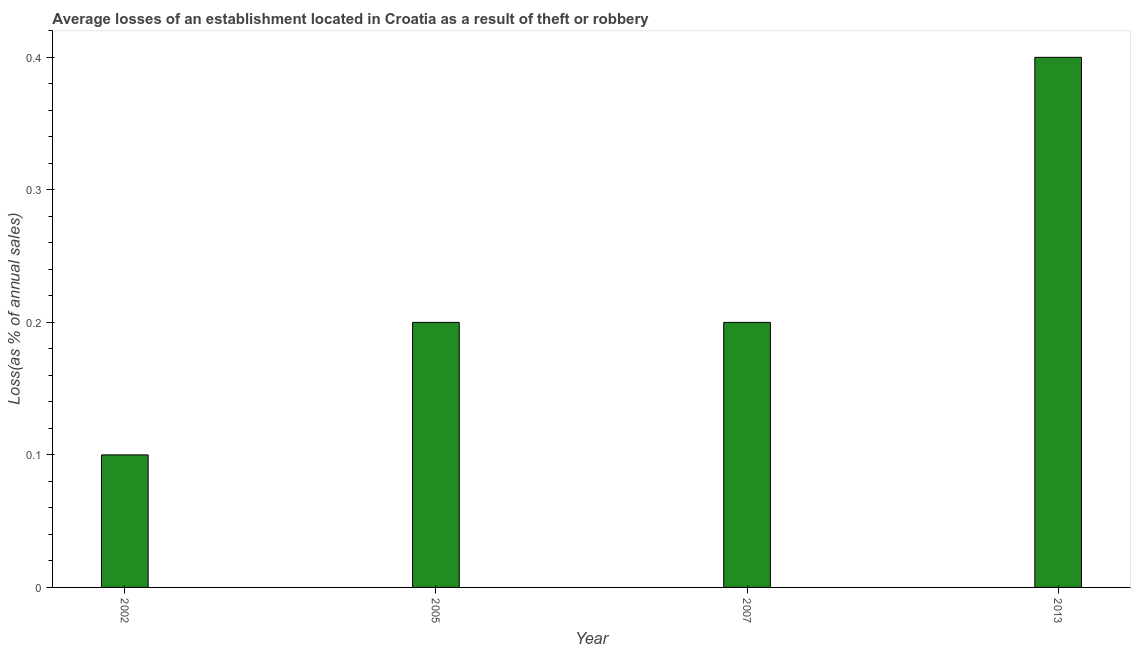Does the graph contain any zero values?
Make the answer very short. No. What is the title of the graph?
Provide a short and direct response. Average losses of an establishment located in Croatia as a result of theft or robbery. What is the label or title of the X-axis?
Provide a succinct answer. Year. What is the label or title of the Y-axis?
Provide a short and direct response. Loss(as % of annual sales). What is the difference between the losses due to theft in 2002 and 2013?
Keep it short and to the point. -0.3. What is the average losses due to theft per year?
Make the answer very short. 0.23. What is the median losses due to theft?
Your response must be concise. 0.2. Do a majority of the years between 2002 and 2007 (inclusive) have losses due to theft greater than 0.2 %?
Ensure brevity in your answer.  No. Is the losses due to theft in 2002 less than that in 2005?
Your answer should be very brief. Yes. Is the sum of the losses due to theft in 2005 and 2013 greater than the maximum losses due to theft across all years?
Your answer should be compact. Yes. What is the difference between the highest and the lowest losses due to theft?
Provide a short and direct response. 0.3. In how many years, is the losses due to theft greater than the average losses due to theft taken over all years?
Your response must be concise. 1. What is the difference between two consecutive major ticks on the Y-axis?
Offer a very short reply. 0.1. What is the Loss(as % of annual sales) of 2007?
Your answer should be compact. 0.2. What is the Loss(as % of annual sales) in 2013?
Keep it short and to the point. 0.4. What is the difference between the Loss(as % of annual sales) in 2002 and 2013?
Keep it short and to the point. -0.3. What is the difference between the Loss(as % of annual sales) in 2005 and 2013?
Offer a very short reply. -0.2. What is the difference between the Loss(as % of annual sales) in 2007 and 2013?
Your response must be concise. -0.2. What is the ratio of the Loss(as % of annual sales) in 2002 to that in 2007?
Your answer should be very brief. 0.5. What is the ratio of the Loss(as % of annual sales) in 2005 to that in 2007?
Offer a very short reply. 1. What is the ratio of the Loss(as % of annual sales) in 2007 to that in 2013?
Ensure brevity in your answer.  0.5. 